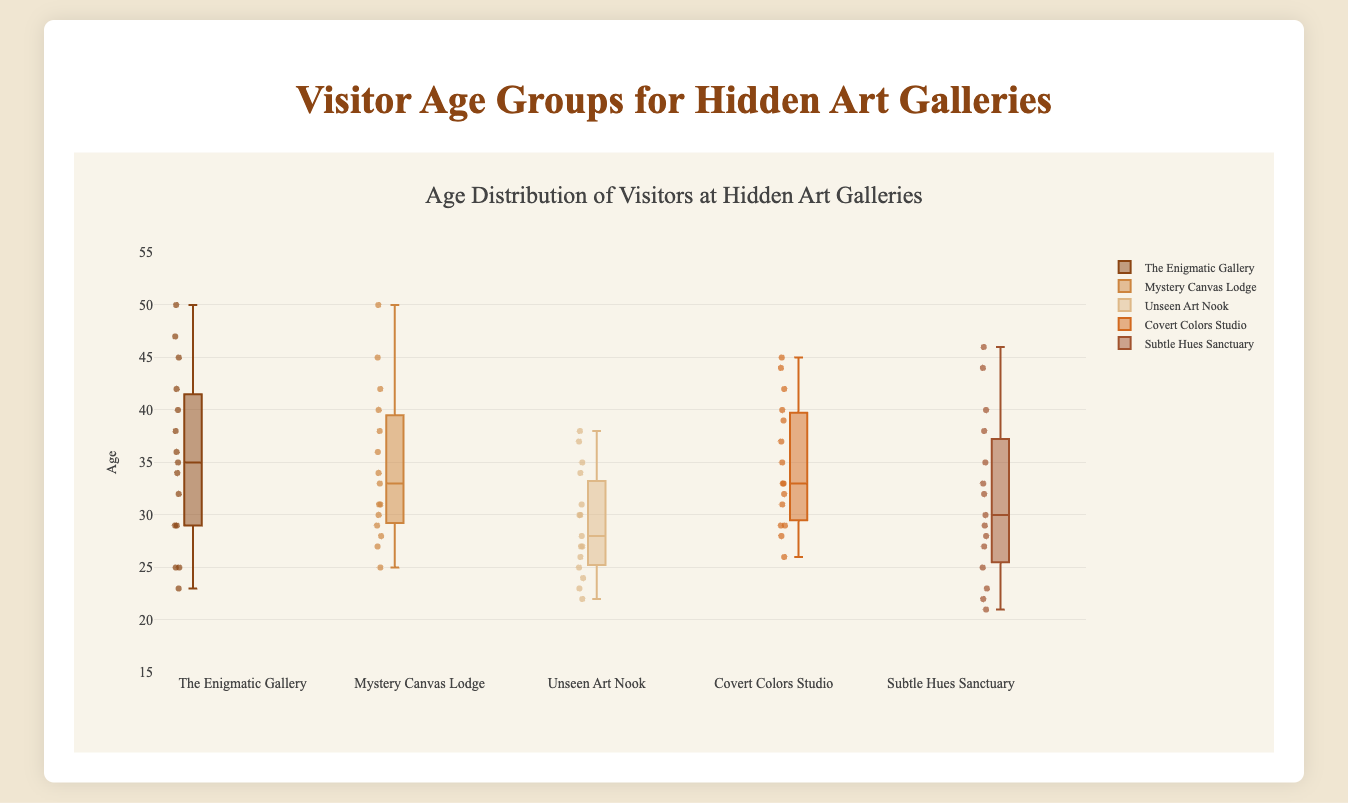What is the title of the plot? The title of the plot is displayed at the top and is usually meant to provide a summary of the content. In this case, the title reads "Age Distribution of Visitors at Hidden Art Galleries".
Answer: Age Distribution of Visitors at Hidden Art Galleries Which gallery has the youngest minimum visitor age? To find the gallery with the youngest minimum visitor age, look at the bottom whiskers of each box plot. The gallery with the lowest point is "Subtle Hues Sanctuary" with a minimum visitor age of 21.
Answer: Subtle Hues Sanctuary What is the median visitor age for The Enigmatic Gallery? Median visitor age is indicated by the line inside each box. For The Enigmatic Gallery, this line is located at age 35.
Answer: 35 Which gallery has the most spread in visitor ages? The spread of data can be judged by looking at the length of the box (interquartile range, IQR) and the whiskers. "The Enigmatic Gallery" appears to have the widest range from its minimum to its maximum visitor age.
Answer: The Enigmatic Gallery Which two galleries have the most similar median visitor ages? By comparing the central lines in each box plot, "The Enigmatic Gallery" and "Covert Colors Studio" have nearly the same median visitor age, around mid-30s.
Answer: The Enigmatic Gallery and Covert Colors Studio Does any gallery have an outlier visitor age of 50? Outliers in the data are represented by individual points outside the whiskers. "The Enigmatic Gallery" and "Mystery Canvas Lodge" both display outliers at age 50.
Answer: The Enigmatic Gallery and Mystery Canvas Lodge Which gallery has the highest maximum visitor age? The top whisker of each box plot indicates the maximum age for each gallery. "Subtle Hues Sanctuary" has the highest maximum visitor age of 46.
Answer: Subtle Hues Sanctuary What is the interquartile range (IQR) of visitors' ages at Unseen Art Nook? The interquartile range is the difference between the third quartile (top of the box) and the first quartile (bottom of the box). For Unseen Art Nook, the ages are approximately 35 (Q3) and 26 (Q1), thus IQR is 35 - 26 = 9.
Answer: 9 Which gallery has the smallest spread in visitor ages? The smallest spread can be identified by the shortest box and whiskers. "Mystery Canvas Lodge" appears to have the smallest spread in visitor ages.
Answer: Mystery Canvas Lodge 